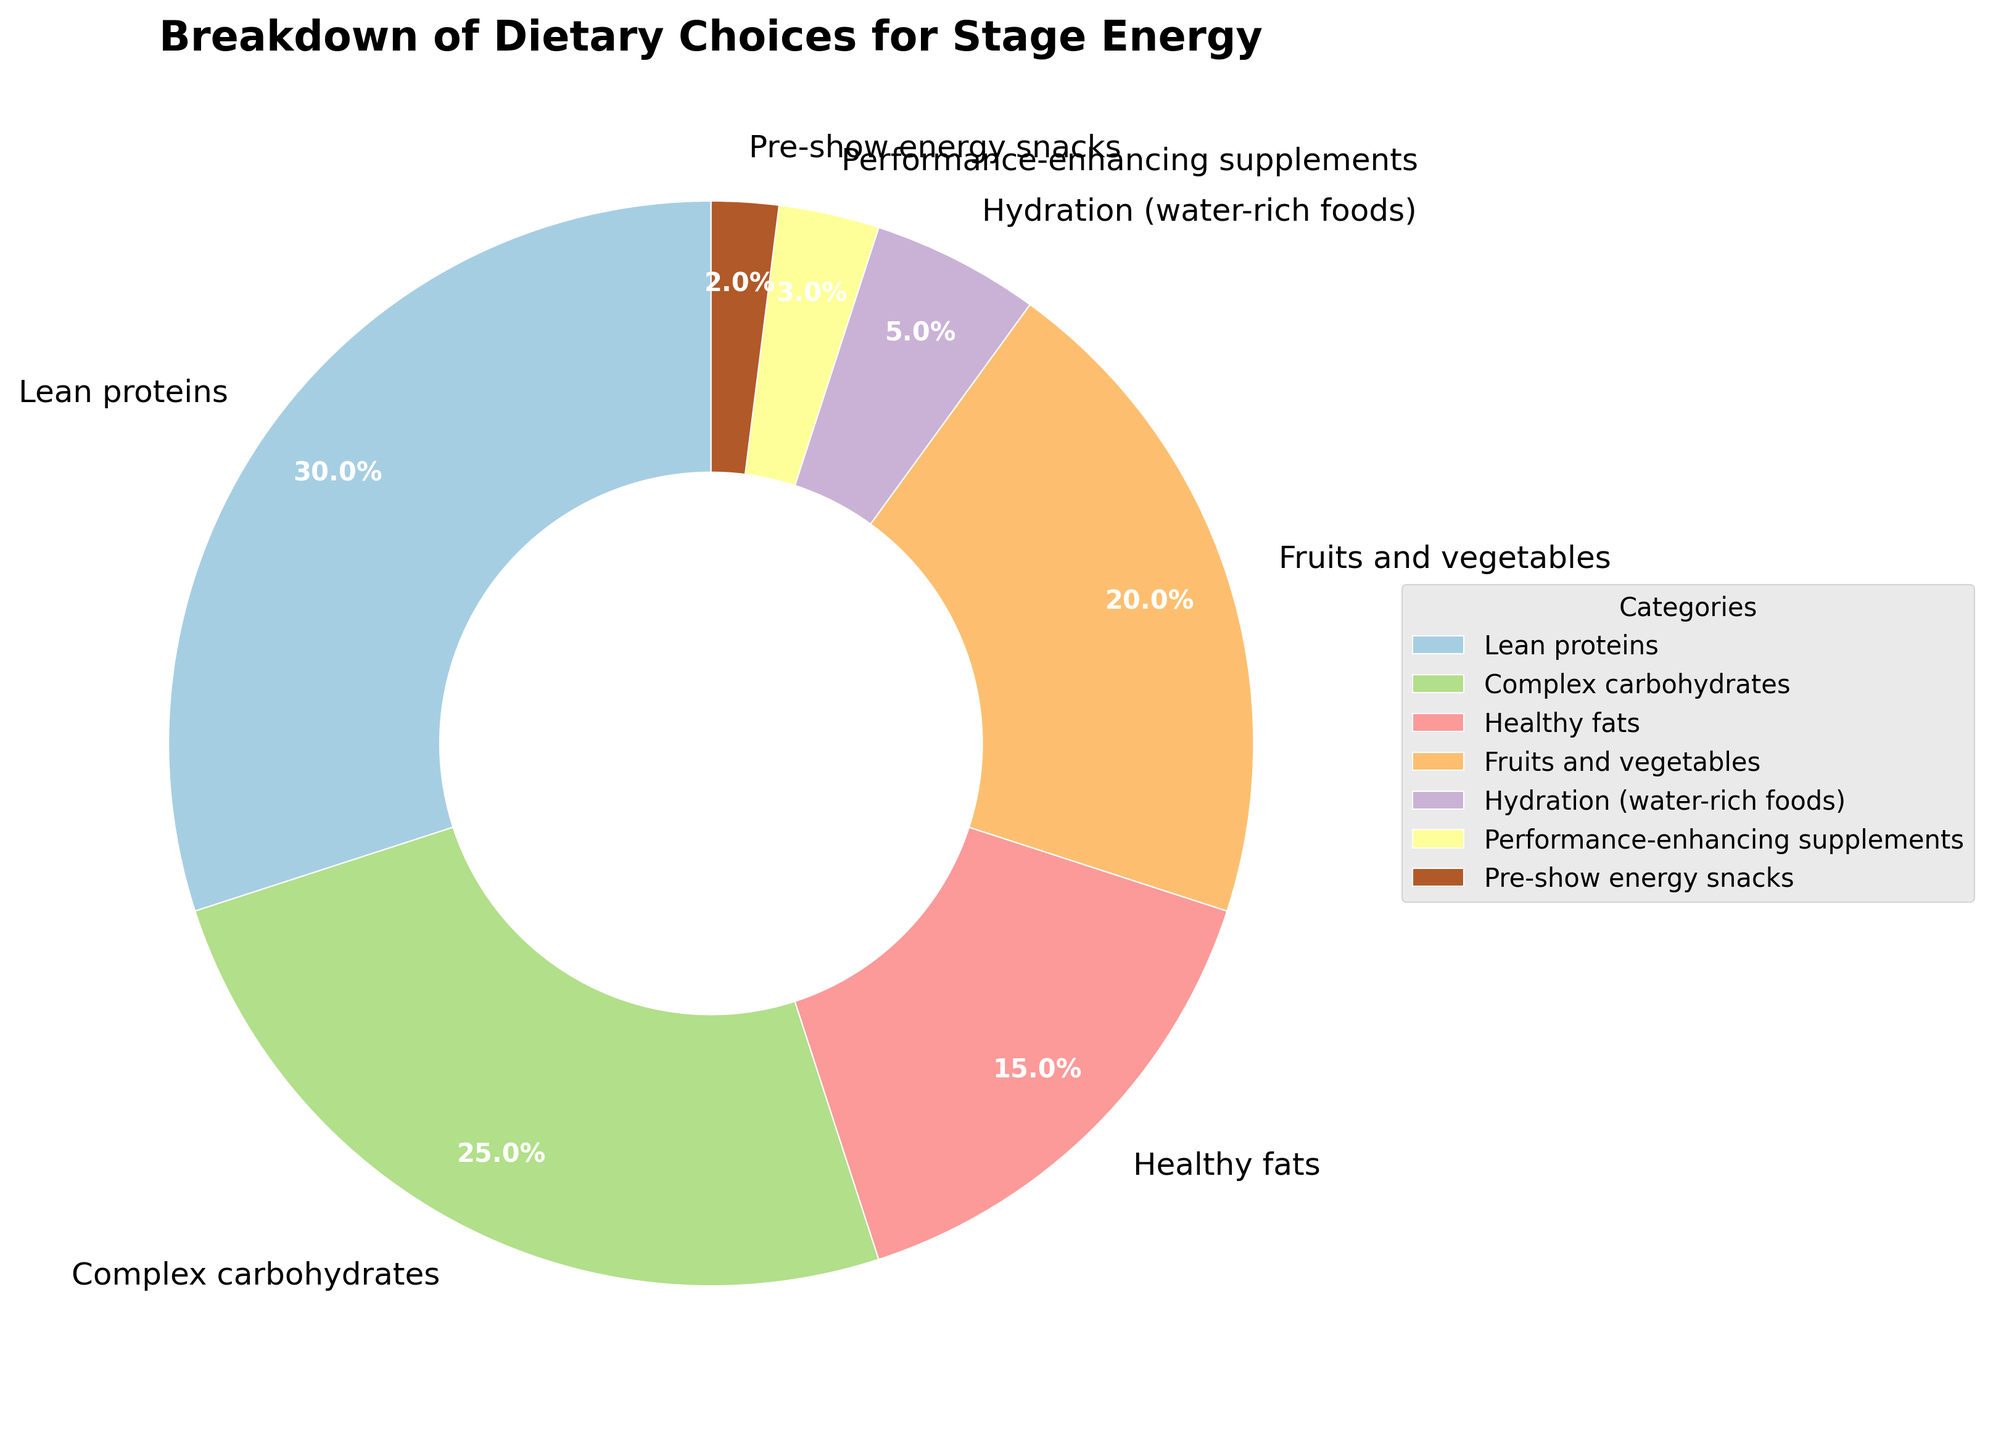What is the largest category in the pie chart? The largest category can be identified by looking for the slice with the greatest percentage indicated. The "Lean proteins" category has the highest percentage of 30%.
Answer: Lean proteins Which category has a smaller percentage: Fruits and vegetables, or Healthy fats? We compare the percentages of the two categories. "Fruits and vegetables" has 20% and "Healthy fats" has 15%. 15% is less than 20%.
Answer: Healthy fats What is the combined percentage of Complex carbohydrates and Healthy fats? Add the percentages of the two categories: Complex carbohydrates (25%) + Healthy fats (15%) = 40%.
Answer: 40% How much more percentage does Lean proteins have compared to Pre-show energy snacks? Subtract the percentage of Pre-show energy snacks from the percentage of Lean proteins: 30% - 2% = 28%.
Answer: 28% Which categories have a percentage of less than 10%? Identify categories with percentages less than 10%. "Hydration (water-rich foods)" at 5%, "Performance-enhancing supplements" at 3%, and "Pre-show energy snacks" at 2% all meet the criteria.
Answer: Hydration (water-rich foods), Performance-enhancing supplements, Pre-show energy snacks What is the average percentage of the categories Fruits and vegetables, Healthy fats, and Hydration (water-rich foods)? Add the percentages of the three categories and divide by the number of categories: (20% + 15% + 5%)/3 = 40%/3 ≈ 13.3%.
Answer: 13.3% Which category is represented by the lightest color in the pie chart? The lightest color typically represents the smallest percentage. "Pre-show energy snacks" has the smallest percentage of 2%, so it is represented by the lightest color.
Answer: Pre-show energy snacks How do the percentages of Complex carbohydrates and Fruits and vegetables compare? Look at the slices for "Complex carbohydrates" (25%) and "Fruits and vegetables" (20%). 25% is greater than 20%.
Answer: Complex carbohydrates is greater What's the total percentage of categories related to hydration and snacks? Add the percentages of "Hydration (water-rich foods)" and "Pre-show energy snacks": 5% + 2% = 7%.
Answer: 7% If the percentage for Performance-enhancing supplements doubled, what would its new percentage be and how would it compare to Healthy fats? Doubling the percentage of Performance-enhancing supplements: 3% * 2 = 6%. Compare this to Healthy fats' 15%. 6% is less than 15%.
Answer: 6%, less 